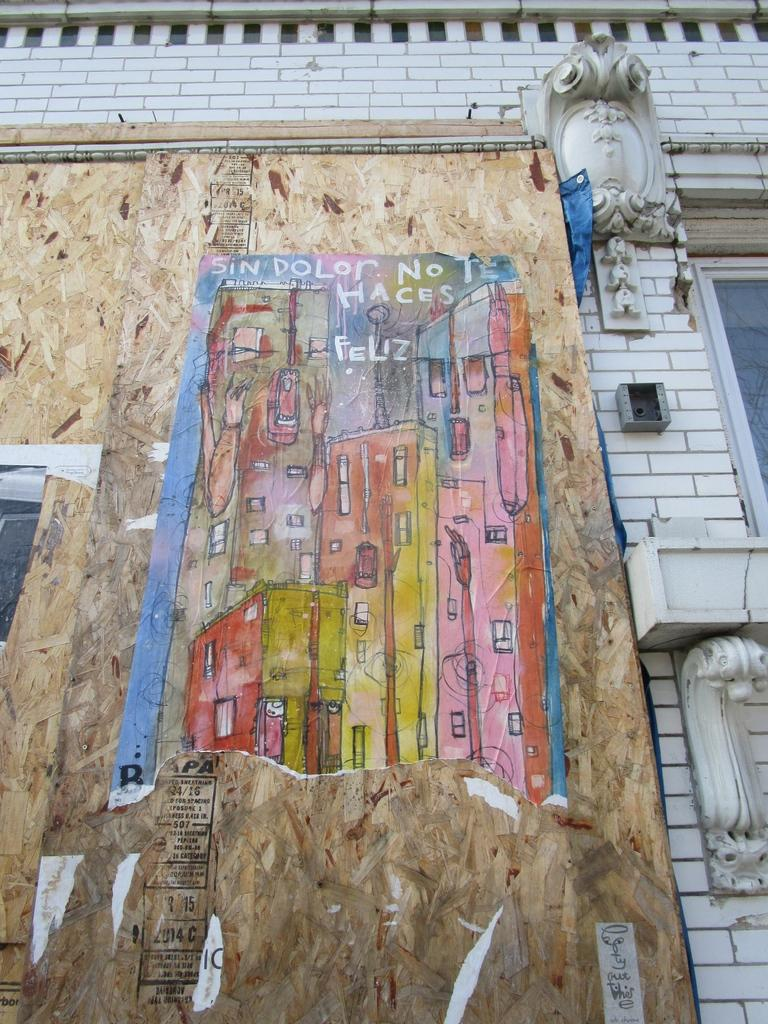What is the main structure visible in the image? There is a building in the image. What is the color of the building? The building is in white color. Is there any additional information or object on the building? Yes, there is a poster pasted on the building. How many knots are tied on the poster in the image? There are no knots present on the poster in the image. What type of curve can be seen on the building in the image? The image does not show any specific curves on the building; it only shows a white building with a poster on it. 